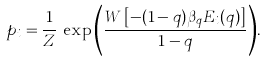Convert formula to latex. <formula><loc_0><loc_0><loc_500><loc_500>p _ { i } = \frac { 1 } { Z } \, \exp { \left ( \frac { W \left [ - ( 1 - q ) \beta _ { q } E _ { i } ( q ) \right ] } { 1 - q } \right ) } .</formula> 